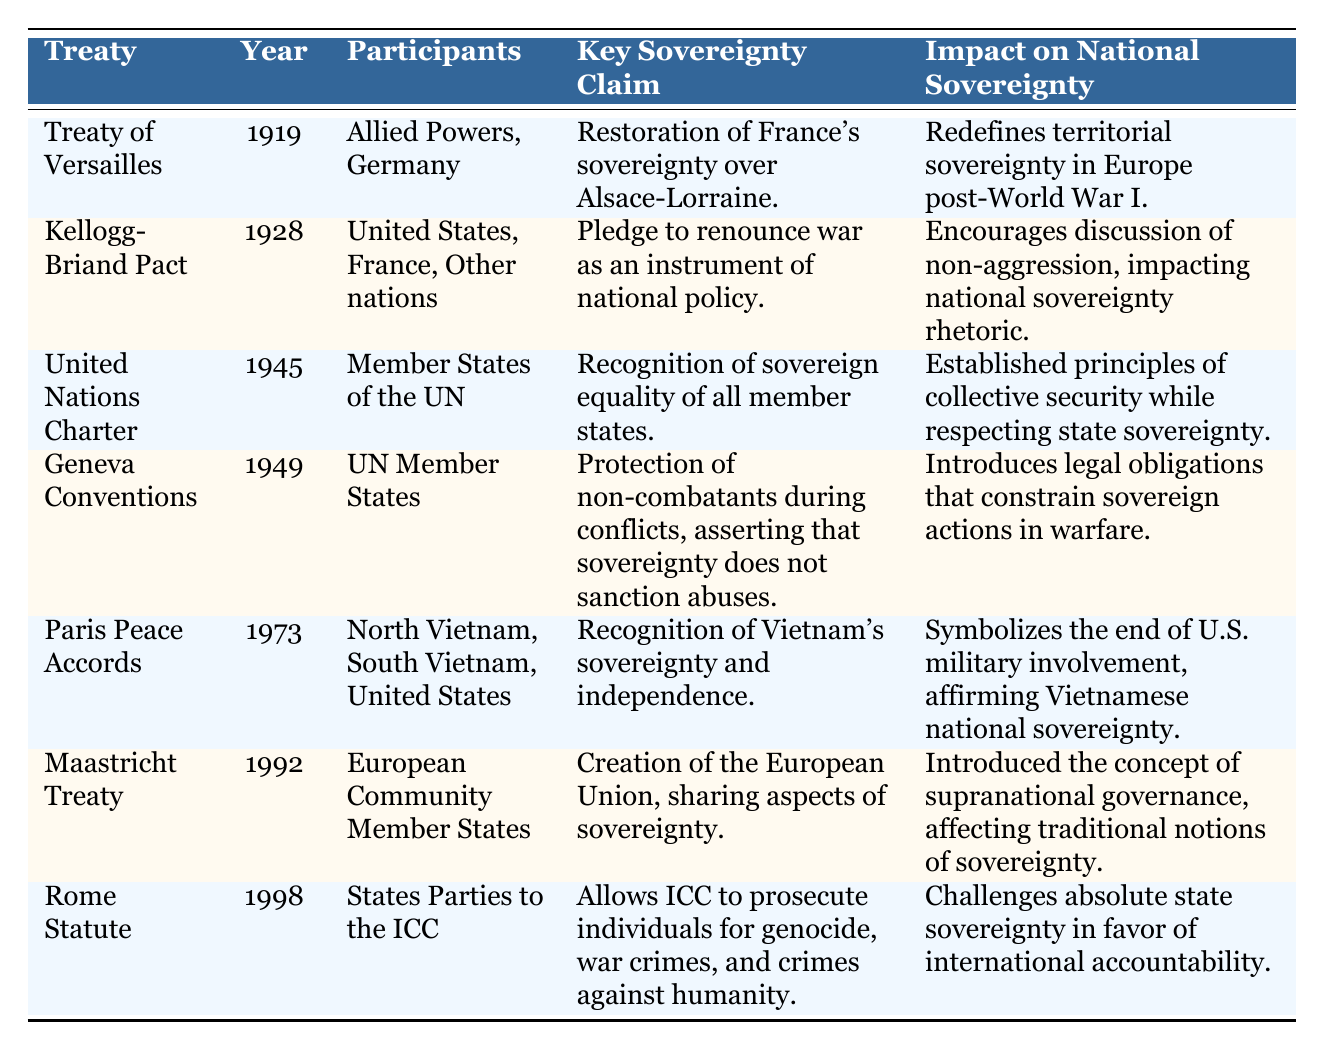What year was the Treaty of Versailles signed? The table lists the Treaty of Versailles under the "Treaty" column, with the corresponding year specified in the "Year" column; it clearly states 1919.
Answer: 1919 What were the key participants in the United Nations Charter? By referencing the "Participants" column for the United Nations Charter, it indicates that the participants are "Member States of the UN."
Answer: Member States of the UN Which treaty introduced the concept of supranational governance? Looking at the "Impact on National Sovereignty" column, the Maastricht Treaty mentions the introduction of supranational governance and affects traditional notions of sovereignty.
Answer: Maastricht Treaty Did the Kellogg-Briand Pact address the renunciation of war? The "Key Sovereignty Claim" column for the Kellogg-Briand Pact states that it includes a pledge to renounce war as an instrument of national policy, indicating that the statement is true.
Answer: Yes What is the relationship between the Geneva Conventions and national sovereignty? The table outlines that the Geneva Conventions introduce legal obligations that constrain sovereign actions in warfare, suggesting a specific relationship where sovereignty does not sanction abuses during conflicts.
Answer: Legal obligations that limit sovereignty How many treaties mentioned in the table focus specifically on sovereignty recognition? The treaties that focus on sovereignty recognition are the Treaty of Versailles, United Nations Charter, Paris Peace Accords, and the Geneva Conventions, adding up to four treaties.
Answer: 4 Which treaty was signed to acknowledge Vietnam’s sovereignty? The "Key Sovereignty Claim" for the Paris Peace Accords specifies recognition of Vietnam’s sovereignty and independence, indicating it is the treaty in question.
Answer: Paris Peace Accords What impact did the Rome Statute have on state sovereignty? The "Impact on National Sovereignty" column for the Rome Statute states it challenges absolute state sovereignty in favor of international accountability, highlighting its significant impact.
Answer: Challenges absolute state sovereignty Identify the treaty that emphasizes the protection of non-combatants. The table indicates the Geneva Conventions include a key sovereignty claim focused on the protection of non-combatants during conflicts, affirming its specific stance on this issue.
Answer: Geneva Conventions 